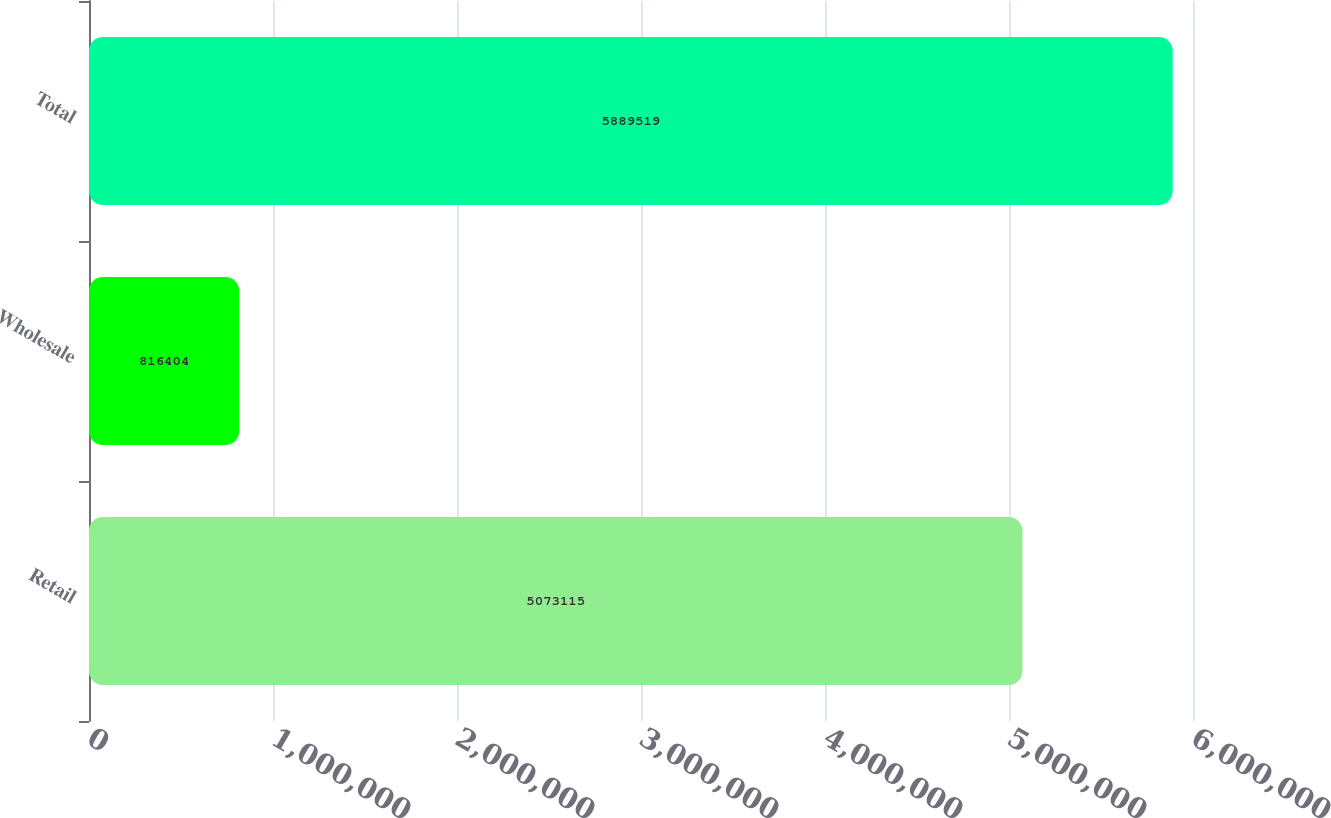<chart> <loc_0><loc_0><loc_500><loc_500><bar_chart><fcel>Retail<fcel>Wholesale<fcel>Total<nl><fcel>5.07312e+06<fcel>816404<fcel>5.88952e+06<nl></chart> 